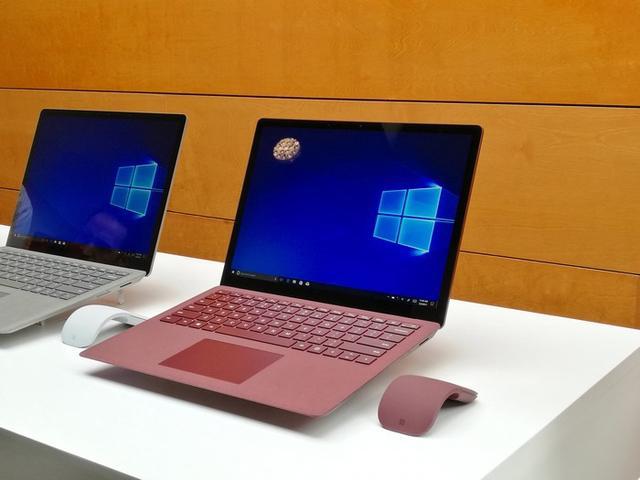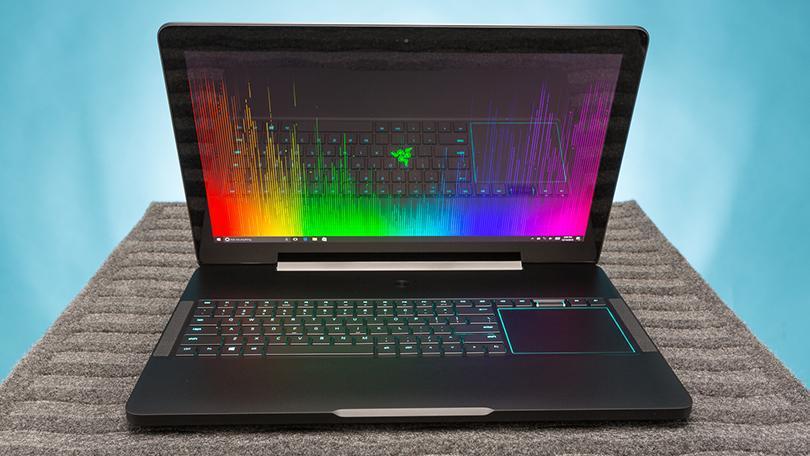The first image is the image on the left, the second image is the image on the right. Considering the images on both sides, is "Both images contain no more than one laptop." valid? Answer yes or no. No. The first image is the image on the left, the second image is the image on the right. Examine the images to the left and right. Is the description "Multiple laptops have the same blue screen showing." accurate? Answer yes or no. Yes. 